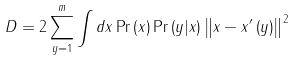Convert formula to latex. <formula><loc_0><loc_0><loc_500><loc_500>D = 2 \sum _ { y = 1 } ^ { m } \int d x \Pr \left ( x \right ) \Pr \left ( y | x \right ) \left \| x - x ^ { \prime } \left ( y \right ) \right \| ^ { 2 }</formula> 